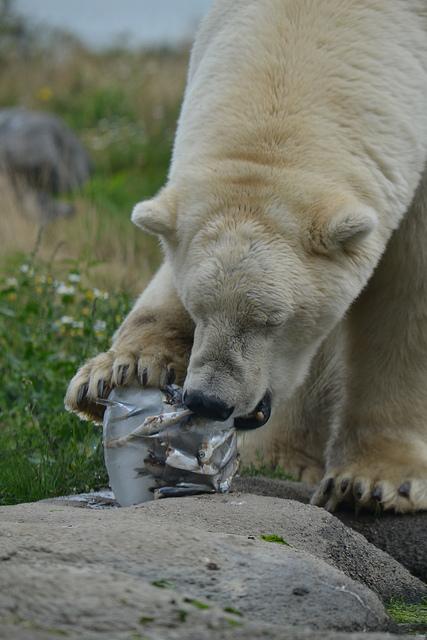What is the dog biting?
Keep it brief. Cup. Is the bear happy?
Answer briefly. Yes. Why are the animals' eyes likely closed?
Be succinct. Enjoying food. What is the bear eating?
Quick response, please. Fish. What type of bear is this?
Be succinct. Polar. Is the bear eating fish?
Short answer required. No. What kind of bear is this?
Short answer required. Polar. Where is the bear?
Quick response, please. Wild. 